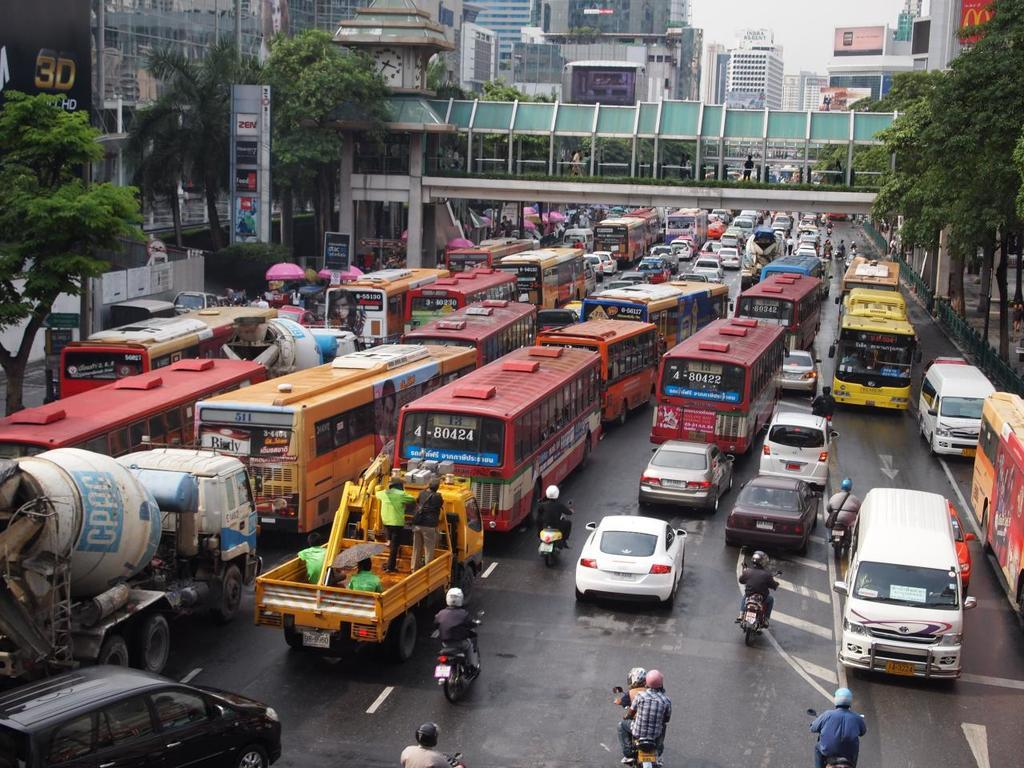What is the main feature of the image? There is a road in the image. What vehicles can be seen on the road? There are cars and buses on the road. What type of structure is present in the image? There is a bridge in the image. What type of natural elements are visible in the image? There are trees in the image. What type of man-made structures can be seen in the image? There are buildings in the image. Can you see any snakes slithering on the road in the image? There are no snakes visible in the image; the vehicles on the road are cars and buses. 